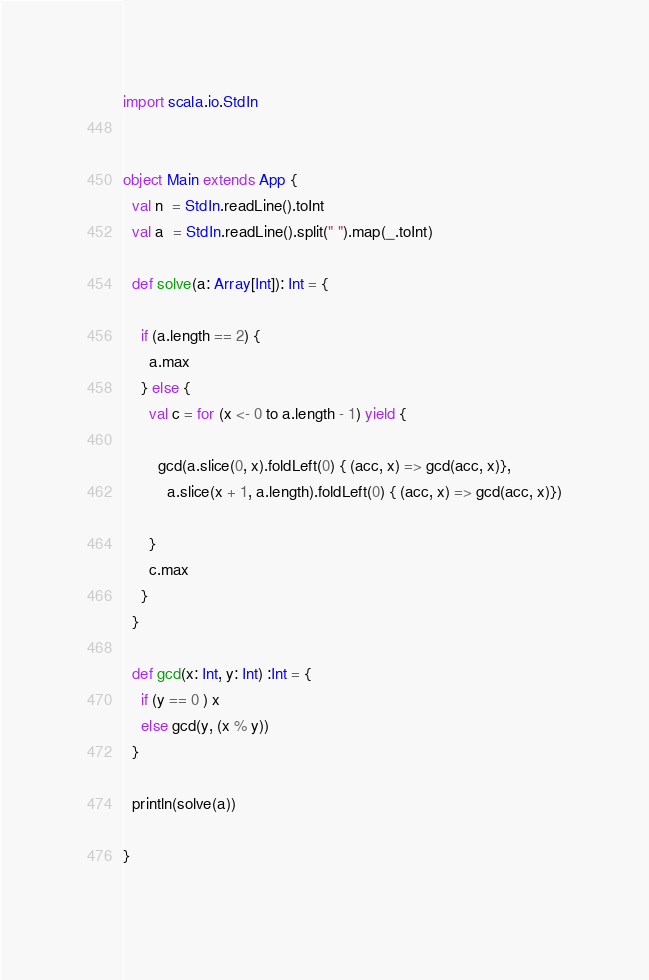<code> <loc_0><loc_0><loc_500><loc_500><_Scala_>import scala.io.StdIn


object Main extends App {
  val n  = StdIn.readLine().toInt
  val a  = StdIn.readLine().split(" ").map(_.toInt)

  def solve(a: Array[Int]): Int = {

    if (a.length == 2) {
      a.max
    } else {
      val c = for (x <- 0 to a.length - 1) yield {
   
        gcd(a.slice(0, x).foldLeft(0) { (acc, x) => gcd(acc, x)},
          a.slice(x + 1, a.length).foldLeft(0) { (acc, x) => gcd(acc, x)})
        
      }
      c.max
    }
  }

  def gcd(x: Int, y: Int) :Int = {
    if (y == 0 ) x
    else gcd(y, (x % y))
  }

  println(solve(a))

}
  

</code> 